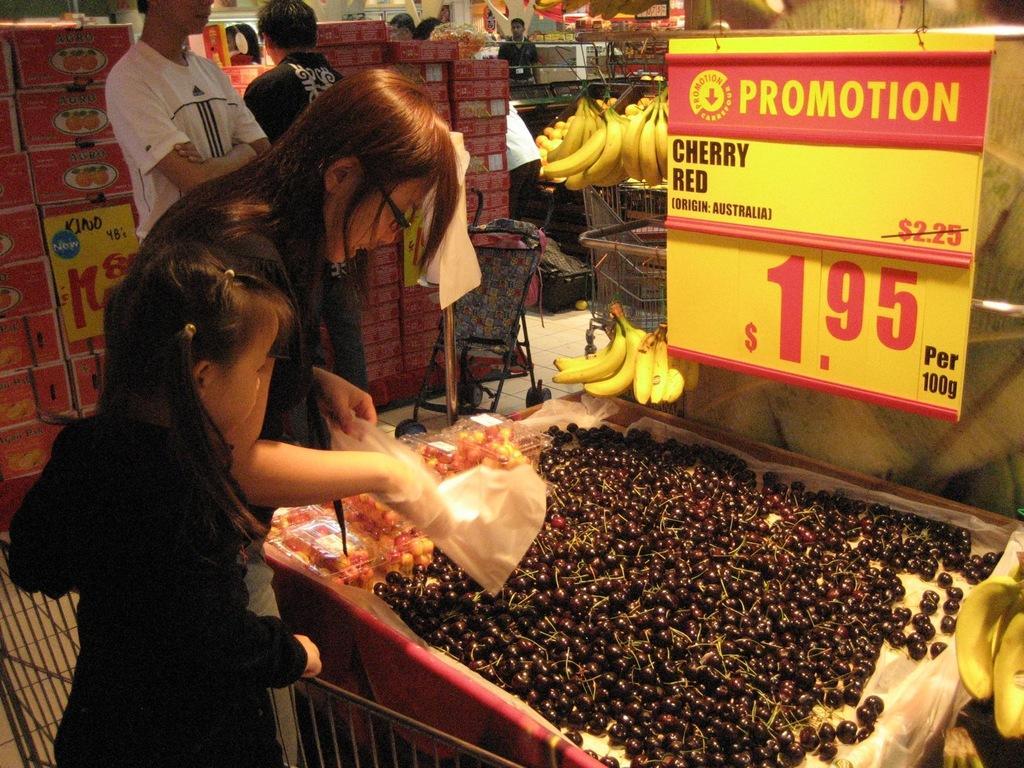Could you give a brief overview of what you see in this image? In the picture we can see a super market with fruits section in it we can see a box full of red cherries and a price board near it and we can see a woman standing and picking some of it and beside her we can see a girl child standing and in the background we can see some people are standing and watching the items and we can also see some bananas. 